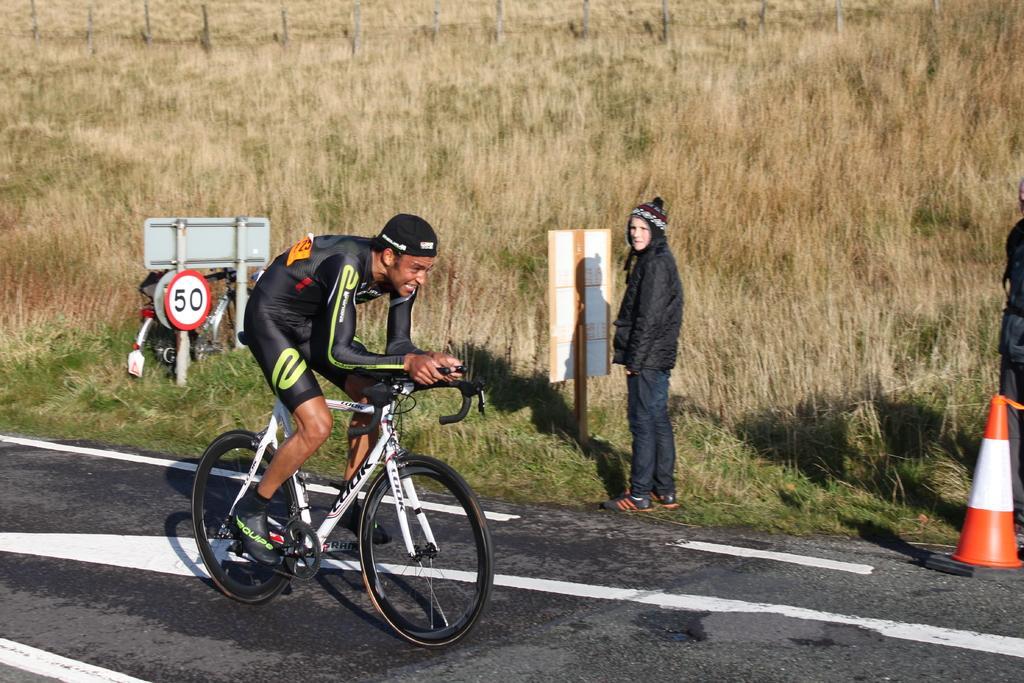In one or two sentences, can you explain what this image depicts? on the road a person is riding a bicycle. he is wearing a black dress and a cap. behind him a person is standing wearing a black coat and a cap. there is a board near her. at the left there is a cycle and board. behind that there is grass and a fencing at the back. 